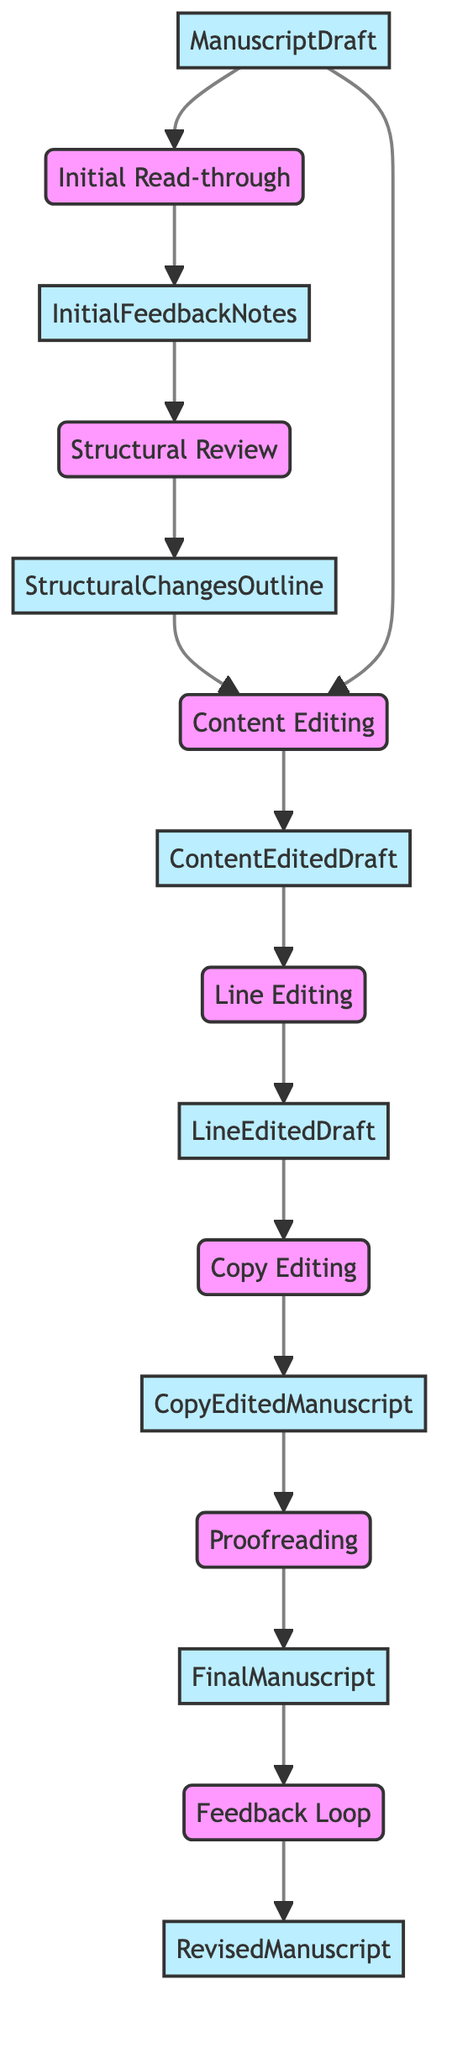What is the first step in the manuscript editing process? The flowchart begins with the "Initial Read-through," which is the first node in the sequence.
Answer: Initial Read-through How many steps are involved in the editing process? Counting each step in the flowchart, there are a total of seven distinct steps outlined from the Initial Read-through to the Revised Manuscript.
Answer: 7 What is the output of the "Proofreading" step? The output of the "Proofreading" step is specified as the "Final Manuscript," which follows the proofreading action in the flowchart.
Answer: Final Manuscript Which two steps take the output from the "Content Editing" step as an input? The "Line Editing" and "Structural Review" steps both take the "Content Edited Draft" as input, as indicated by the connections in the diagram.
Answer: Line Editing, Structural Review What happens after "Feedback Loop"? According to the flowchart, "Revised Manuscript" is the final output after completing the "Feedback Loop," marking the end of the editing process.
Answer: Revised Manuscript Which step focuses on checking grammar and punctuation errors? The "Copy Editing" step is specifically dedicated to checking for grammar, punctuation, and syntax errors, as described in its definition within the flowchart.
Answer: Copy Editing What is the input for the "Structural Review" step? The input that feeds into the "Structural Review" step is "Initial Feedback Notes," which were generated during the initial read-through.
Answer: Initial Feedback Notes Which step immediately follows "Line Editing"? The step that follows "Line Editing" is "Copy Editing," as indicated by the flowchart sequence that connects these two nodes.
Answer: Copy Editing 